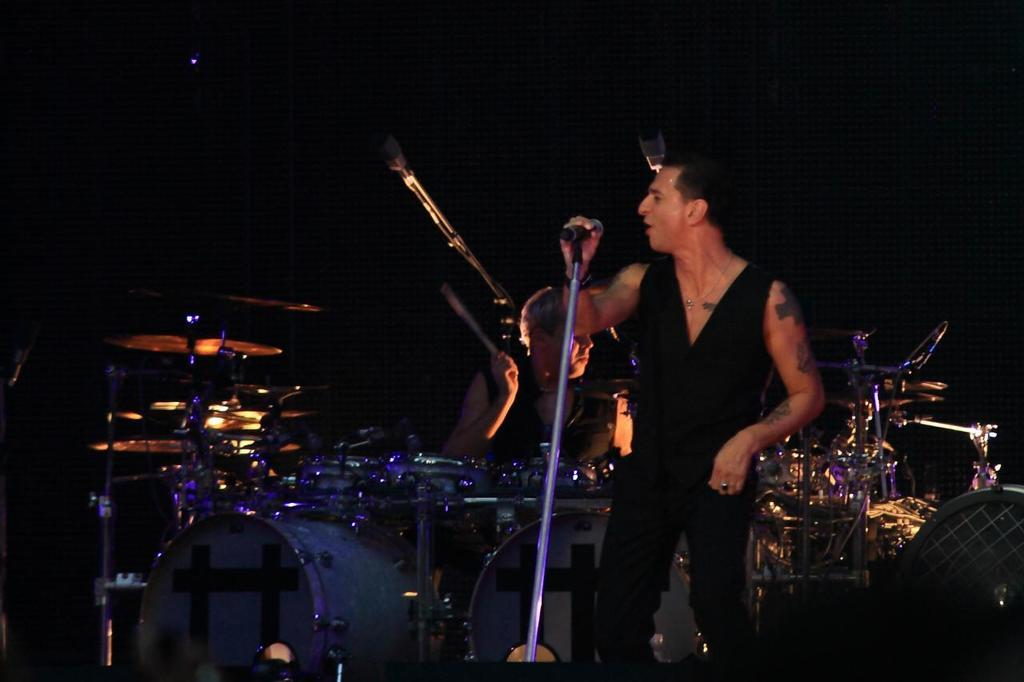What is the man in the image doing? The man is standing and singing in the image. What is the man holding while singing? The man is holding a microphone. What color is the dress the man is wearing? The man is wearing a black color dress. What is the other man in the image doing? The other man is sitting and beating drums. Is there a cake being served to the passengers in the image? There is no cake or passengers present in the image; it features two men, one singing and the other playing drums. 